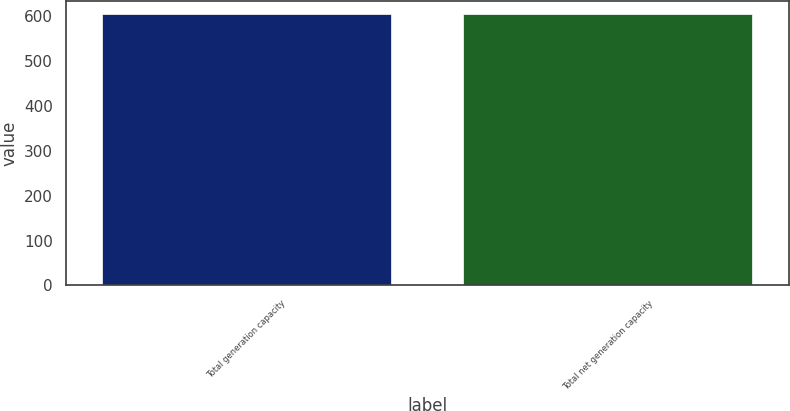Convert chart. <chart><loc_0><loc_0><loc_500><loc_500><bar_chart><fcel>Total generation capacity<fcel>Total net generation capacity<nl><fcel>605<fcel>605.1<nl></chart> 